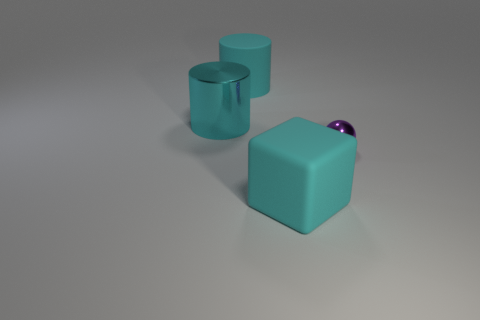Does the thing that is to the right of the big block have the same material as the cyan block?
Offer a very short reply. No. What material is the sphere?
Offer a terse response. Metal. There is a cyan object in front of the small purple object; what size is it?
Ensure brevity in your answer.  Large. Are there any other things that have the same color as the large rubber block?
Make the answer very short. Yes. There is a object that is to the right of the cyan thing that is in front of the tiny purple thing; is there a small ball that is in front of it?
Your answer should be compact. No. There is a big cylinder that is on the right side of the large cyan metallic cylinder; is it the same color as the block?
Offer a terse response. Yes. How many balls are tiny purple things or large cyan objects?
Provide a succinct answer. 1. What is the shape of the metallic object that is on the left side of the cyan object that is on the right side of the large cyan rubber cylinder?
Make the answer very short. Cylinder. There is a shiny object that is left of the cyan cylinder to the right of the shiny thing left of the small purple object; how big is it?
Ensure brevity in your answer.  Large. Do the rubber cylinder and the metallic ball have the same size?
Offer a terse response. No. 